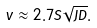<formula> <loc_0><loc_0><loc_500><loc_500>v \approx 2 . 7 S \sqrt { J D } .</formula> 